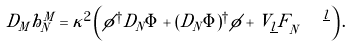Convert formula to latex. <formula><loc_0><loc_0><loc_500><loc_500>D _ { M } h ^ { M } _ { N } = \kappa ^ { 2 } \left ( \phi ^ { \dagger } D _ { N } \Phi + ( D _ { N } \Phi ) ^ { \dagger } \phi + V _ { \underline { l } } F _ { N } ^ { \quad \underline { l } } \right ) .</formula> 